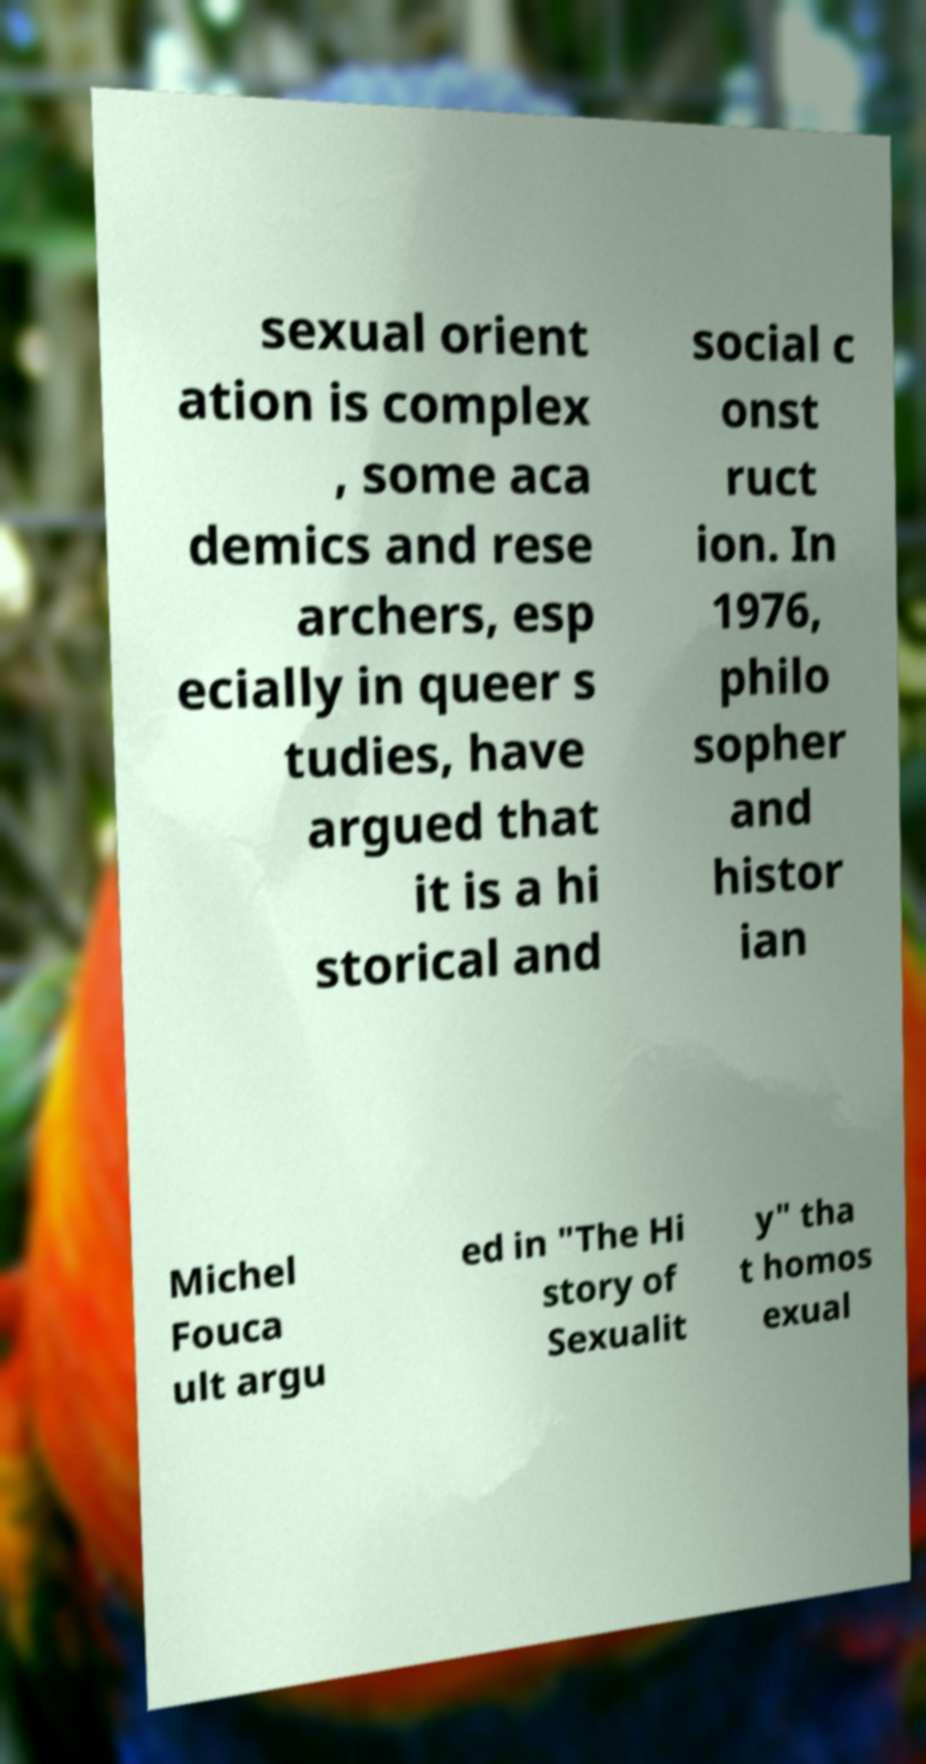There's text embedded in this image that I need extracted. Can you transcribe it verbatim? sexual orient ation is complex , some aca demics and rese archers, esp ecially in queer s tudies, have argued that it is a hi storical and social c onst ruct ion. In 1976, philo sopher and histor ian Michel Fouca ult argu ed in "The Hi story of Sexualit y" tha t homos exual 